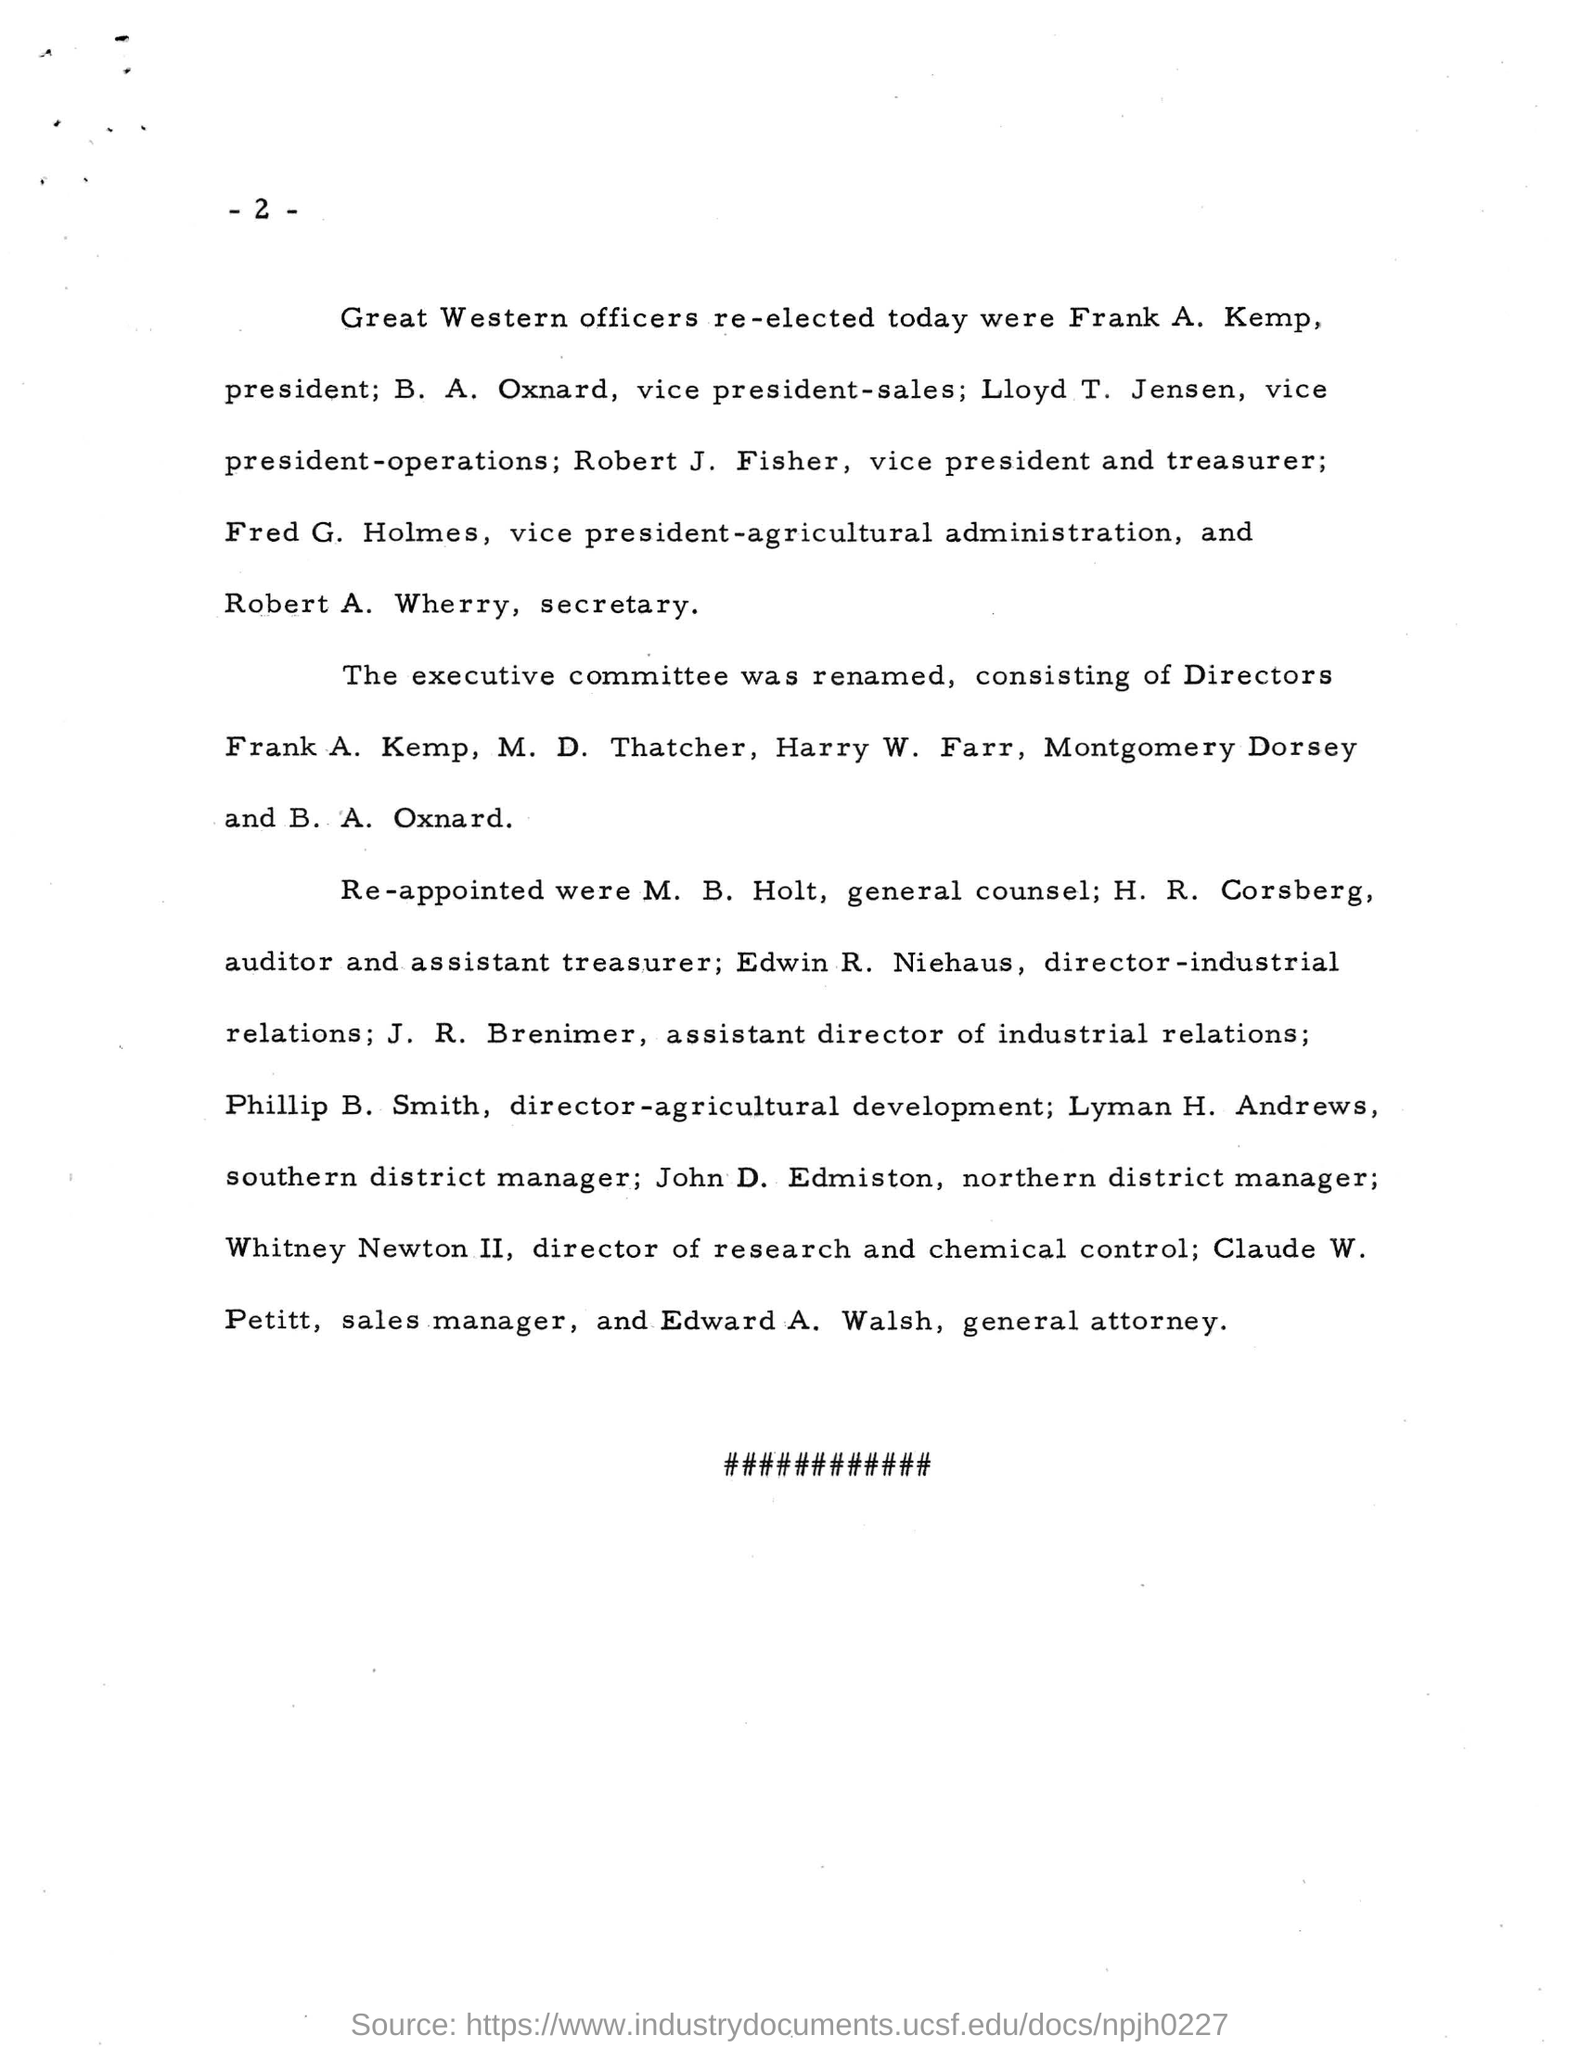Outline some significant characteristics in this image. Edward A. Walsh is the General Attorney. The President of Great Western Officers is Frank A. Kemp. The person named Claude W. Petit is the sales manager. 